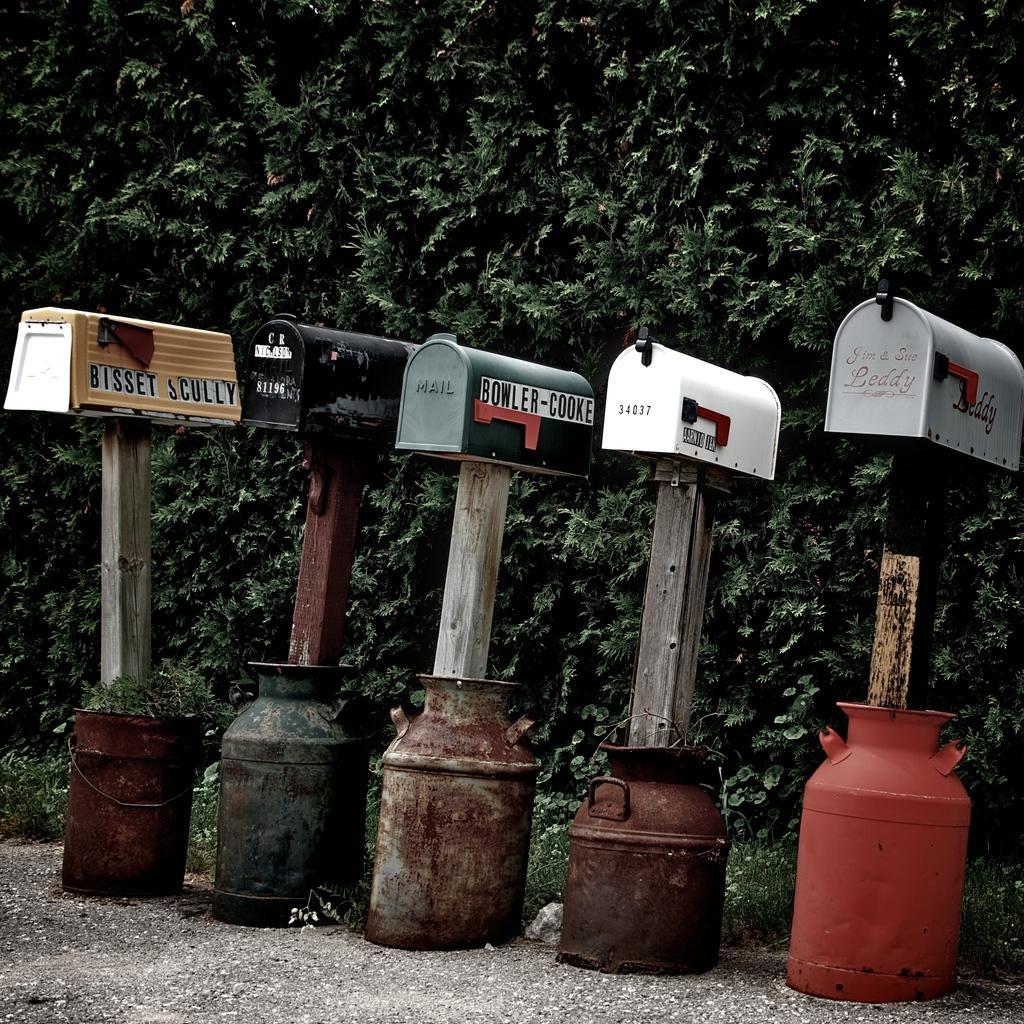How would you summarize this image in a sentence or two? Here I can see few boxes are attached to the wooden poles and these wooden poles are placed in the metal cans which are placed on the ground. In the background, I can see the leaves of plants. 